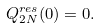Convert formula to latex. <formula><loc_0><loc_0><loc_500><loc_500>Q _ { 2 N } ^ { r e s } ( 0 ) = 0 .</formula> 